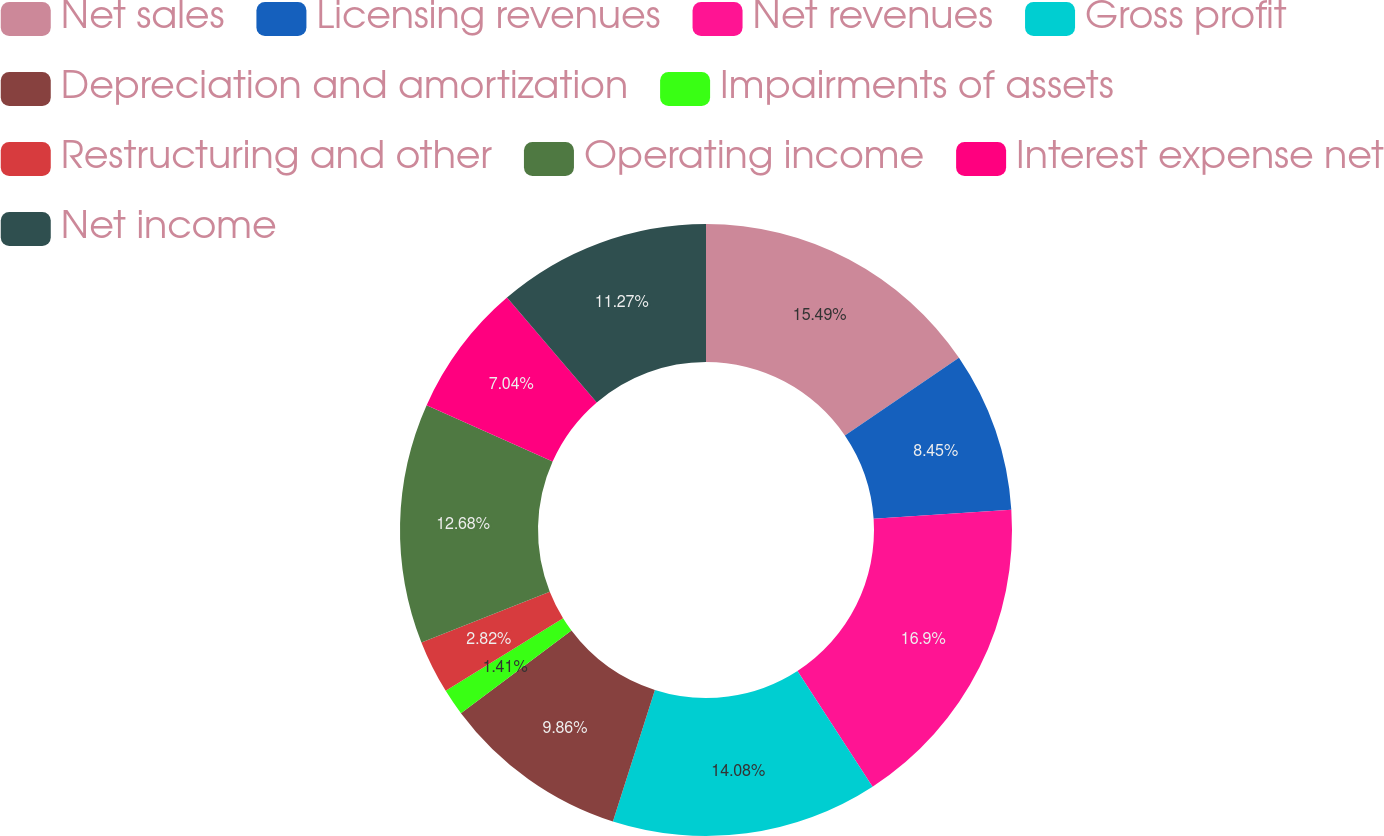Convert chart to OTSL. <chart><loc_0><loc_0><loc_500><loc_500><pie_chart><fcel>Net sales<fcel>Licensing revenues<fcel>Net revenues<fcel>Gross profit<fcel>Depreciation and amortization<fcel>Impairments of assets<fcel>Restructuring and other<fcel>Operating income<fcel>Interest expense net<fcel>Net income<nl><fcel>15.49%<fcel>8.45%<fcel>16.9%<fcel>14.08%<fcel>9.86%<fcel>1.41%<fcel>2.82%<fcel>12.68%<fcel>7.04%<fcel>11.27%<nl></chart> 